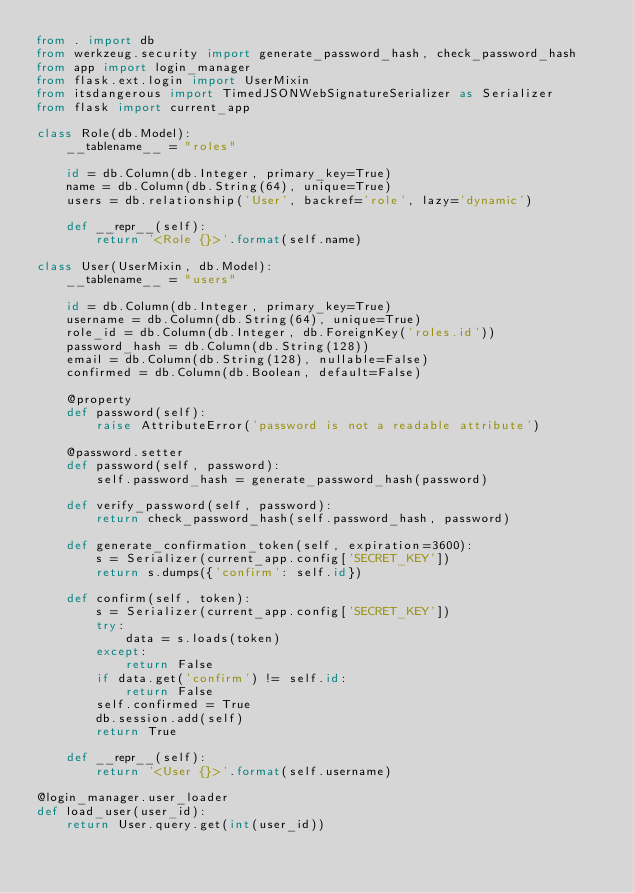<code> <loc_0><loc_0><loc_500><loc_500><_Python_>from . import db
from werkzeug.security import generate_password_hash, check_password_hash
from app import login_manager
from flask.ext.login import UserMixin
from itsdangerous import TimedJSONWebSignatureSerializer as Serializer
from flask import current_app

class Role(db.Model):
    __tablename__ = "roles"

    id = db.Column(db.Integer, primary_key=True)
    name = db.Column(db.String(64), unique=True)
    users = db.relationship('User', backref='role', lazy='dynamic')

    def __repr__(self):
        return '<Role {}>'.format(self.name)

class User(UserMixin, db.Model):
    __tablename__ = "users"

    id = db.Column(db.Integer, primary_key=True)
    username = db.Column(db.String(64), unique=True)
    role_id = db.Column(db.Integer, db.ForeignKey('roles.id'))
    password_hash = db.Column(db.String(128))
    email = db.Column(db.String(128), nullable=False)
    confirmed = db.Column(db.Boolean, default=False)

    @property
    def password(self):
        raise AttributeError('password is not a readable attribute')

    @password.setter
    def password(self, password):
        self.password_hash = generate_password_hash(password)

    def verify_password(self, password):
        return check_password_hash(self.password_hash, password)

    def generate_confirmation_token(self, expiration=3600):
        s = Serializer(current_app.config['SECRET_KEY'])
        return s.dumps({'confirm': self.id})

    def confirm(self, token):
        s = Serializer(current_app.config['SECRET_KEY'])
        try:
            data = s.loads(token)
        except:
            return False
        if data.get('confirm') != self.id:
            return False
        self.confirmed = True
        db.session.add(self)
        return True

    def __repr__(self):
        return '<User {}>'.format(self.username)

@login_manager.user_loader
def load_user(user_id):
    return User.query.get(int(user_id))

</code> 